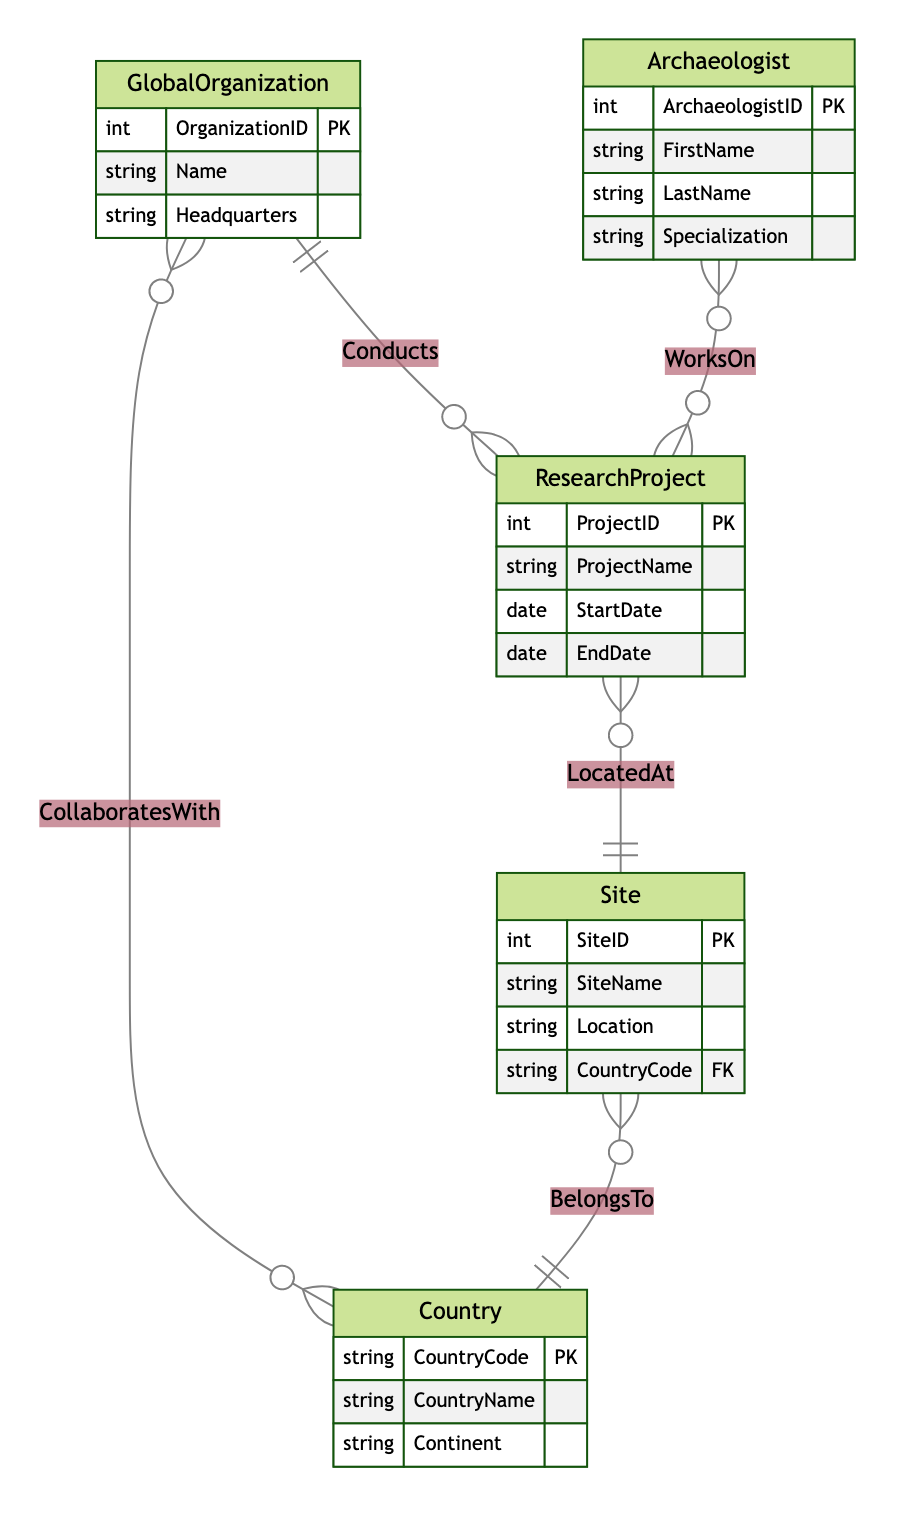What is the primary key of the Global Organization entity? The primary key of the Global Organization entity is "OrganizationID". This is specified in the attributes list for the Global Organization in the diagram data.
Answer: OrganizationID How many attributes does the Country entity have? The Country entity has three attributes: "CountryCode", "CountryName", and "Continent". By counting these attributes in the provided data, we confirm this number.
Answer: 3 What is the relationship between Global Organization and Research Project? The relationship between Global Organization and Research Project is defined as "Conducts", indicating that a global organization can conduct multiple research projects. This is shown as a one-to-many relationship in the diagram.
Answer: Conducts How many entities are connected to Research Project? There are three entities connected to Research Project: Global Organization, Site, and Archaeologist. By reviewing the relationships defined in the diagram, we can see these connections.
Answer: 3 Which entity has a many-to-many relationship with Archaeologist? The Research Project entity has a many-to-many relationship with the Archaeologist entity through the "WorksOn" relationship. This means multiple archaeologists can work on multiple research projects.
Answer: Research Project What is the foreign key in the Site entity? The foreign key in the Site entity is "CountryCode". This is indicated in the attributes list of the Site entity, denoting that it links to the Country entity.
Answer: CountryCode Which entity is the end of the "LocatedAt" relationship? The end of the "LocatedAt" relationship is the Site entity, as it is the one that research projects are located at. This is defined in the relationship description in the diagram.
Answer: Site How many research projects can one Global Organization conduct? A Global Organization can conduct many research projects, as indicated by the one-to-many relationship established between Global Organization and Research Project.
Answer: Many What type of relationship is established between Global Organization and Country? The relationship established between Global Organization and Country is a many-to-many relationship named "CollaboratesWith", which indicates multiple global organizations can collaborate with multiple countries.
Answer: Many-to-Many 